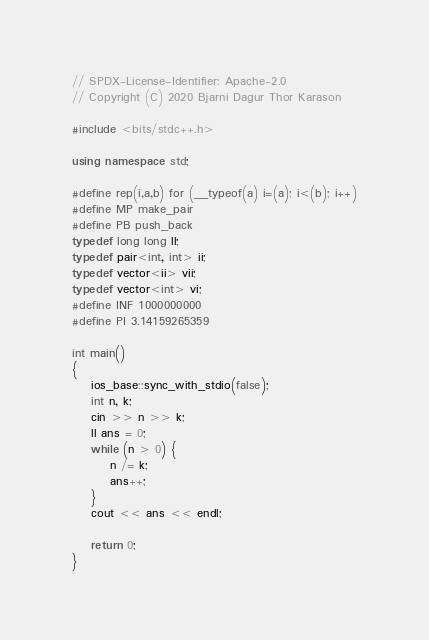Convert code to text. <code><loc_0><loc_0><loc_500><loc_500><_C++_>// SPDX-License-Identifier: Apache-2.0
// Copyright (C) 2020 Bjarni Dagur Thor Karason

#include <bits/stdc++.h>

using namespace std;

#define rep(i,a,b) for (__typeof(a) i=(a); i<(b); i++)
#define MP make_pair
#define PB push_back
typedef long long ll;
typedef pair<int, int> ii;
typedef vector<ii> vii;
typedef vector<int> vi;
#define INF 1000000000
#define PI 3.14159265359

int main()
{
    ios_base::sync_with_stdio(false);
    int n, k;
    cin >> n >> k;
    ll ans = 0;
    while (n > 0) {
        n /= k;
        ans++;
    }
    cout << ans << endl;

    return 0;
}</code> 